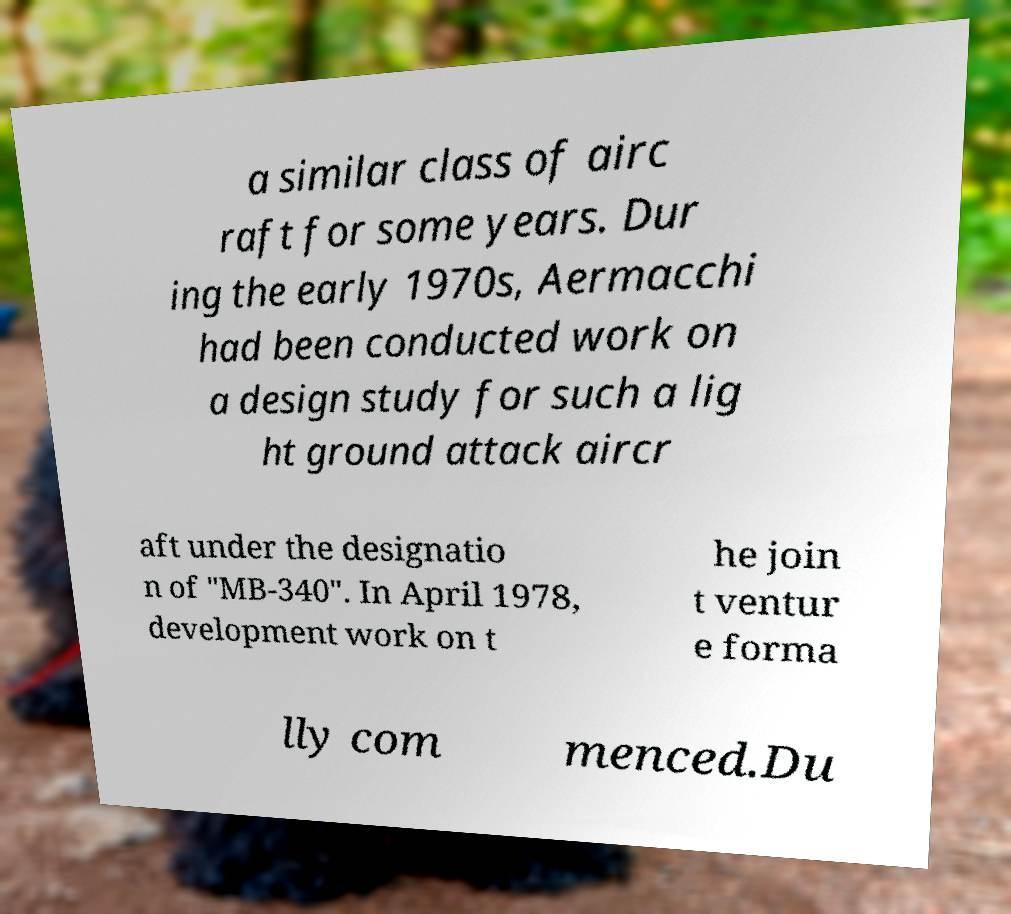Please identify and transcribe the text found in this image. a similar class of airc raft for some years. Dur ing the early 1970s, Aermacchi had been conducted work on a design study for such a lig ht ground attack aircr aft under the designatio n of "MB-340". In April 1978, development work on t he join t ventur e forma lly com menced.Du 